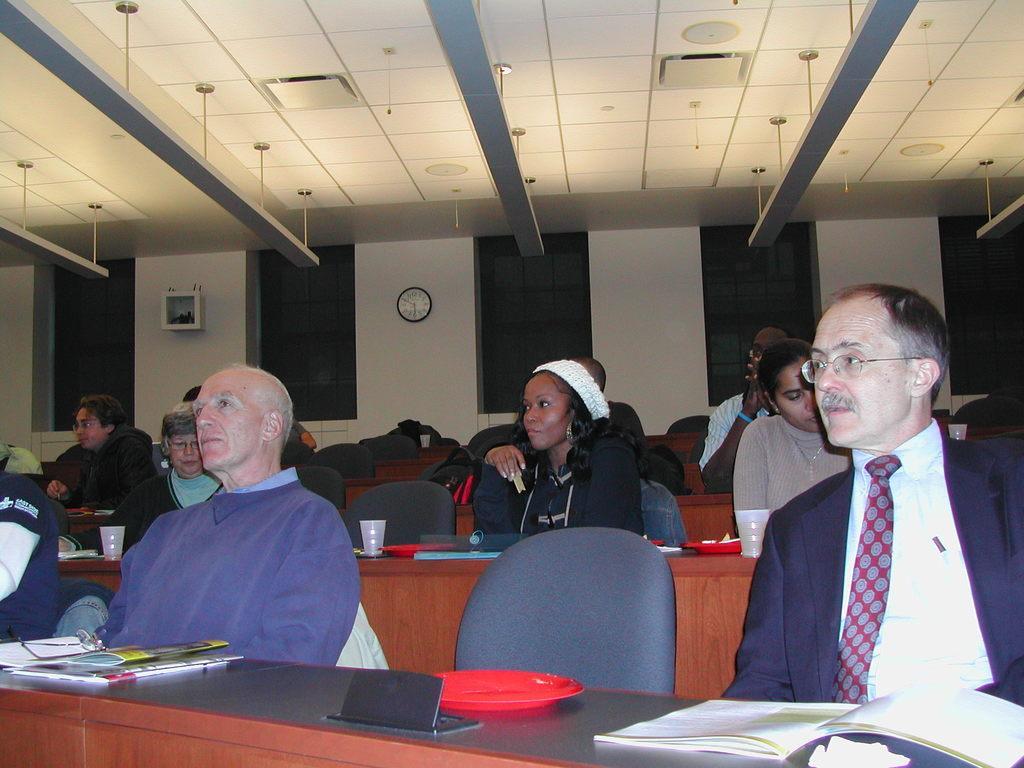In one or two sentences, can you explain what this image depicts? In this picture we can see people sitting on chairs, here we can see books, cups and some objects and in the background we can see a wall, clock, roof and some objects. 